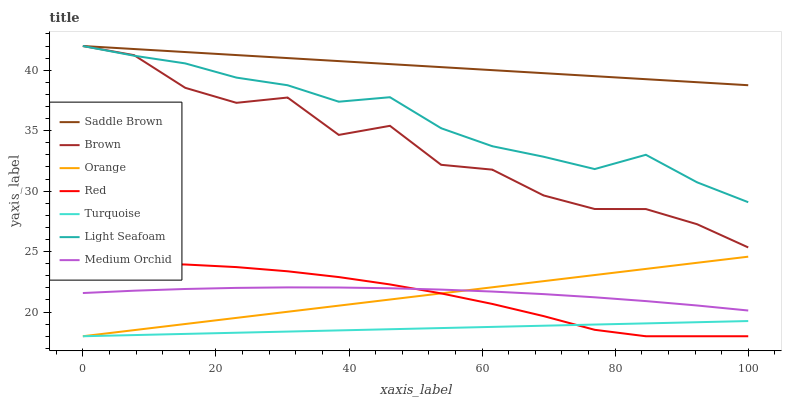Does Turquoise have the minimum area under the curve?
Answer yes or no. Yes. Does Saddle Brown have the maximum area under the curve?
Answer yes or no. Yes. Does Medium Orchid have the minimum area under the curve?
Answer yes or no. No. Does Medium Orchid have the maximum area under the curve?
Answer yes or no. No. Is Orange the smoothest?
Answer yes or no. Yes. Is Brown the roughest?
Answer yes or no. Yes. Is Turquoise the smoothest?
Answer yes or no. No. Is Turquoise the roughest?
Answer yes or no. No. Does Turquoise have the lowest value?
Answer yes or no. Yes. Does Medium Orchid have the lowest value?
Answer yes or no. No. Does Saddle Brown have the highest value?
Answer yes or no. Yes. Does Medium Orchid have the highest value?
Answer yes or no. No. Is Turquoise less than Saddle Brown?
Answer yes or no. Yes. Is Brown greater than Orange?
Answer yes or no. Yes. Does Light Seafoam intersect Saddle Brown?
Answer yes or no. Yes. Is Light Seafoam less than Saddle Brown?
Answer yes or no. No. Is Light Seafoam greater than Saddle Brown?
Answer yes or no. No. Does Turquoise intersect Saddle Brown?
Answer yes or no. No. 